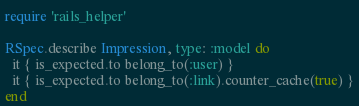Convert code to text. <code><loc_0><loc_0><loc_500><loc_500><_Ruby_>require 'rails_helper'

RSpec.describe Impression, type: :model do
  it { is_expected.to belong_to(:user) }
  it { is_expected.to belong_to(:link).counter_cache(true) }
end
</code> 